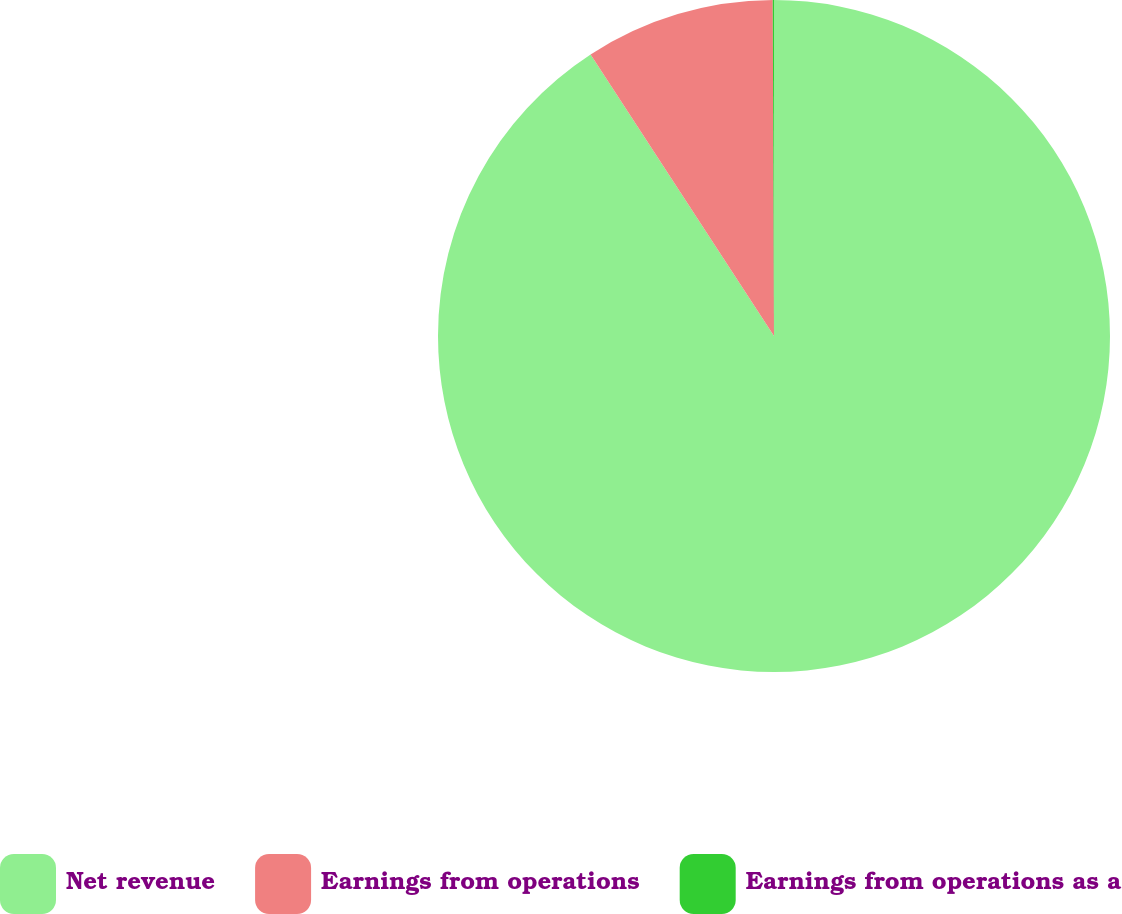Convert chart to OTSL. <chart><loc_0><loc_0><loc_500><loc_500><pie_chart><fcel>Net revenue<fcel>Earnings from operations<fcel>Earnings from operations as a<nl><fcel>90.81%<fcel>9.13%<fcel>0.06%<nl></chart> 